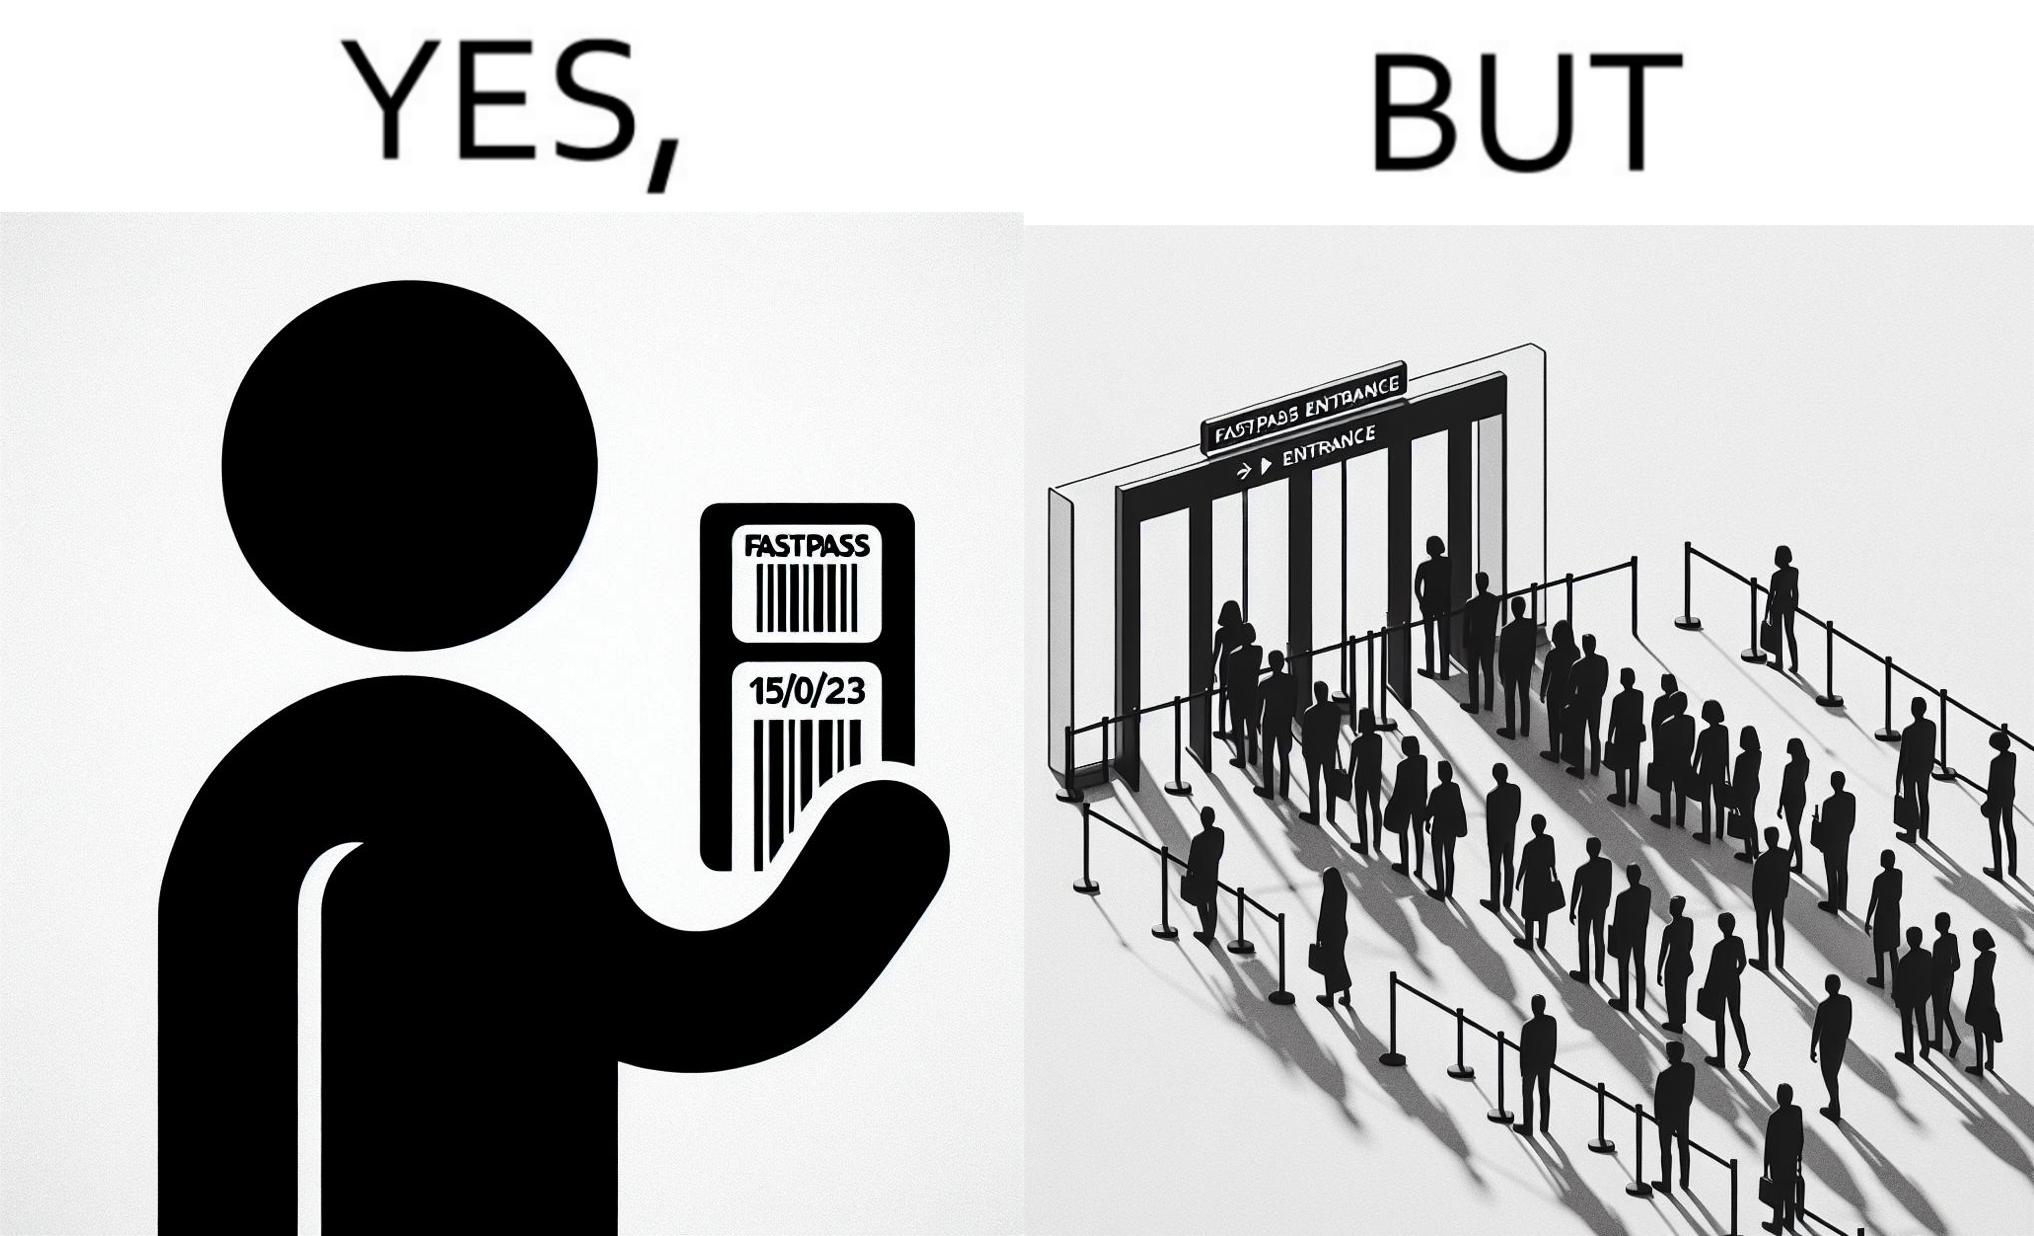Describe the content of this image. The image is ironic, because fast pass entrance was meant for people to pass the gate fast but as more no. of people bought the pass due to which the queue has become longer and it becomes slow and time consuming 